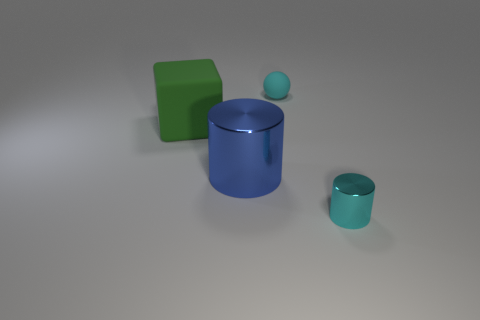Subtract 2 cylinders. How many cylinders are left? 0 Subtract all blue cylinders. How many cylinders are left? 1 Add 3 cyan rubber things. How many objects exist? 7 Subtract all balls. How many objects are left? 3 Add 2 big red objects. How many big red objects exist? 2 Subtract 0 green balls. How many objects are left? 4 Subtract all purple blocks. Subtract all gray balls. How many blocks are left? 1 Subtract all blue balls. How many blue cylinders are left? 1 Subtract all tiny gray metallic cubes. Subtract all tiny matte spheres. How many objects are left? 3 Add 2 cyan things. How many cyan things are left? 4 